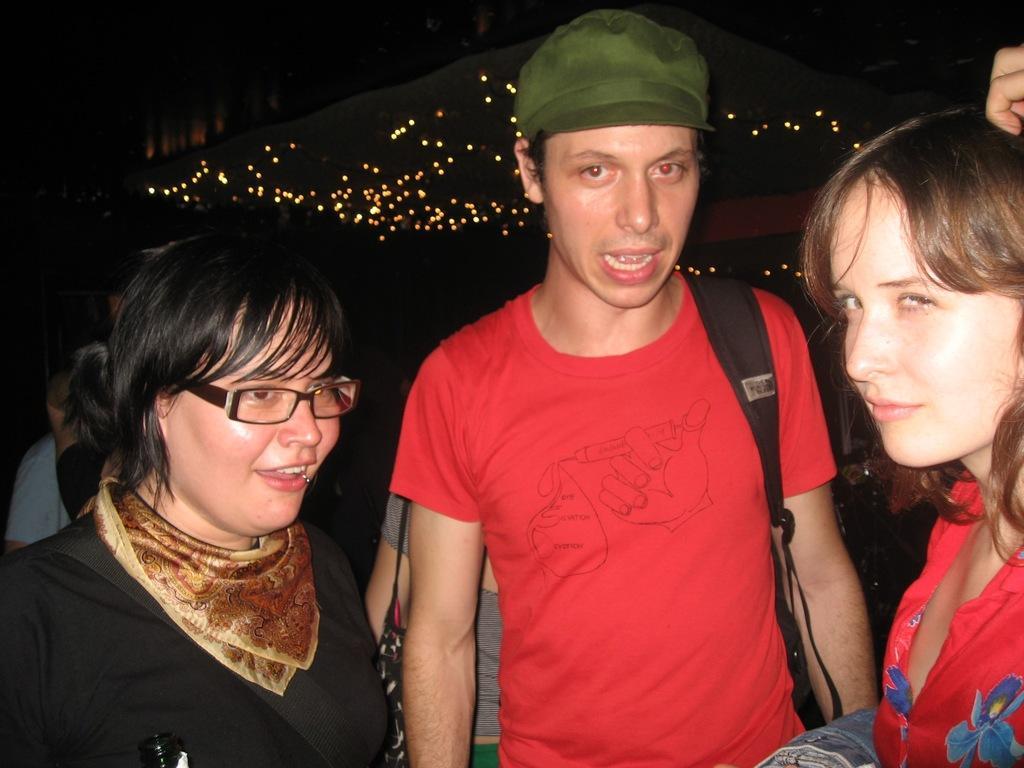Describe this image in one or two sentences. In this image there are people standing, in the background there are lights. 